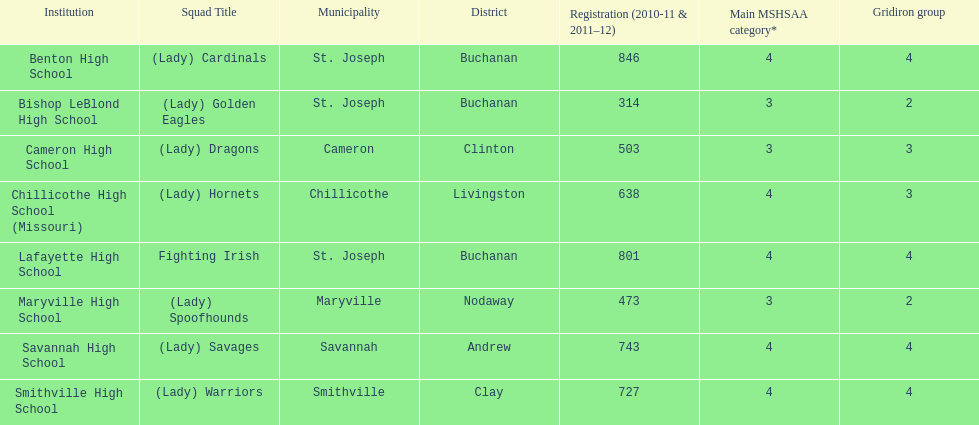What school has 3 football classes but only has 638 student enrollment? Chillicothe High School (Missouri). 